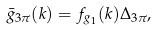<formula> <loc_0><loc_0><loc_500><loc_500>\bar { g } _ { 3 \pi } ( k ) = f _ { g _ { 1 } } ( k ) \Delta _ { 3 \pi } ,</formula> 